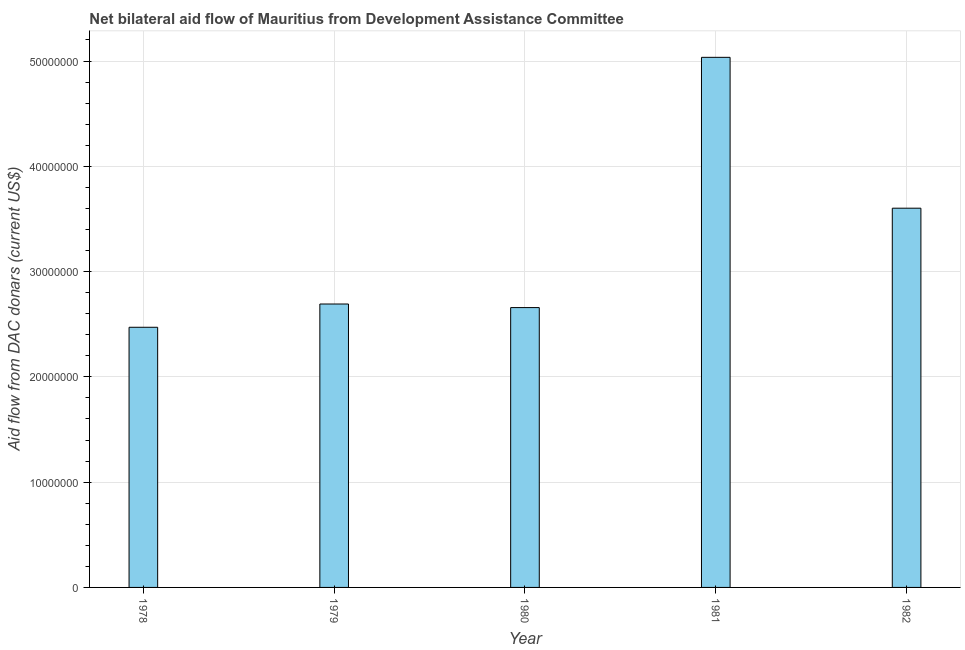Does the graph contain any zero values?
Ensure brevity in your answer.  No. What is the title of the graph?
Your answer should be very brief. Net bilateral aid flow of Mauritius from Development Assistance Committee. What is the label or title of the Y-axis?
Offer a terse response. Aid flow from DAC donars (current US$). What is the net bilateral aid flows from dac donors in 1982?
Offer a terse response. 3.60e+07. Across all years, what is the maximum net bilateral aid flows from dac donors?
Your response must be concise. 5.04e+07. Across all years, what is the minimum net bilateral aid flows from dac donors?
Your answer should be very brief. 2.47e+07. In which year was the net bilateral aid flows from dac donors minimum?
Your answer should be very brief. 1978. What is the sum of the net bilateral aid flows from dac donors?
Offer a very short reply. 1.65e+08. What is the difference between the net bilateral aid flows from dac donors in 1981 and 1982?
Offer a very short reply. 1.43e+07. What is the average net bilateral aid flows from dac donors per year?
Make the answer very short. 3.29e+07. What is the median net bilateral aid flows from dac donors?
Offer a very short reply. 2.69e+07. What is the ratio of the net bilateral aid flows from dac donors in 1979 to that in 1981?
Make the answer very short. 0.54. Is the difference between the net bilateral aid flows from dac donors in 1979 and 1981 greater than the difference between any two years?
Ensure brevity in your answer.  No. What is the difference between the highest and the second highest net bilateral aid flows from dac donors?
Give a very brief answer. 1.43e+07. What is the difference between the highest and the lowest net bilateral aid flows from dac donors?
Ensure brevity in your answer.  2.56e+07. In how many years, is the net bilateral aid flows from dac donors greater than the average net bilateral aid flows from dac donors taken over all years?
Provide a short and direct response. 2. How many bars are there?
Give a very brief answer. 5. Are all the bars in the graph horizontal?
Give a very brief answer. No. How many years are there in the graph?
Provide a succinct answer. 5. Are the values on the major ticks of Y-axis written in scientific E-notation?
Ensure brevity in your answer.  No. What is the Aid flow from DAC donars (current US$) in 1978?
Keep it short and to the point. 2.47e+07. What is the Aid flow from DAC donars (current US$) of 1979?
Make the answer very short. 2.69e+07. What is the Aid flow from DAC donars (current US$) of 1980?
Make the answer very short. 2.66e+07. What is the Aid flow from DAC donars (current US$) in 1981?
Provide a short and direct response. 5.04e+07. What is the Aid flow from DAC donars (current US$) of 1982?
Make the answer very short. 3.60e+07. What is the difference between the Aid flow from DAC donars (current US$) in 1978 and 1979?
Make the answer very short. -2.21e+06. What is the difference between the Aid flow from DAC donars (current US$) in 1978 and 1980?
Offer a very short reply. -1.87e+06. What is the difference between the Aid flow from DAC donars (current US$) in 1978 and 1981?
Your answer should be compact. -2.56e+07. What is the difference between the Aid flow from DAC donars (current US$) in 1978 and 1982?
Provide a short and direct response. -1.13e+07. What is the difference between the Aid flow from DAC donars (current US$) in 1979 and 1981?
Keep it short and to the point. -2.34e+07. What is the difference between the Aid flow from DAC donars (current US$) in 1979 and 1982?
Your answer should be very brief. -9.10e+06. What is the difference between the Aid flow from DAC donars (current US$) in 1980 and 1981?
Offer a very short reply. -2.38e+07. What is the difference between the Aid flow from DAC donars (current US$) in 1980 and 1982?
Your response must be concise. -9.44e+06. What is the difference between the Aid flow from DAC donars (current US$) in 1981 and 1982?
Keep it short and to the point. 1.43e+07. What is the ratio of the Aid flow from DAC donars (current US$) in 1978 to that in 1979?
Offer a terse response. 0.92. What is the ratio of the Aid flow from DAC donars (current US$) in 1978 to that in 1981?
Your response must be concise. 0.49. What is the ratio of the Aid flow from DAC donars (current US$) in 1978 to that in 1982?
Keep it short and to the point. 0.69. What is the ratio of the Aid flow from DAC donars (current US$) in 1979 to that in 1981?
Give a very brief answer. 0.54. What is the ratio of the Aid flow from DAC donars (current US$) in 1979 to that in 1982?
Your answer should be very brief. 0.75. What is the ratio of the Aid flow from DAC donars (current US$) in 1980 to that in 1981?
Your response must be concise. 0.53. What is the ratio of the Aid flow from DAC donars (current US$) in 1980 to that in 1982?
Offer a very short reply. 0.74. What is the ratio of the Aid flow from DAC donars (current US$) in 1981 to that in 1982?
Your answer should be very brief. 1.4. 